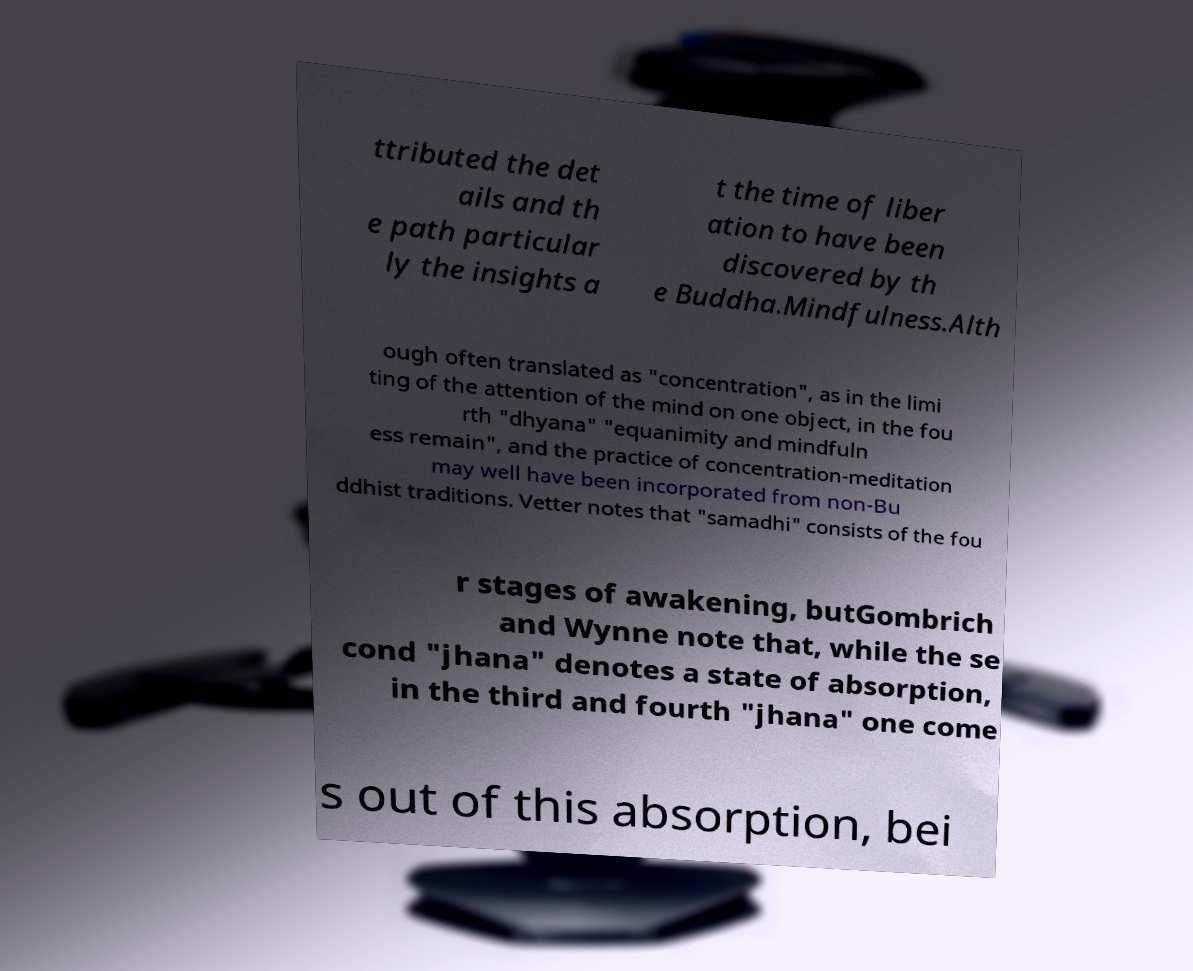Can you accurately transcribe the text from the provided image for me? ttributed the det ails and th e path particular ly the insights a t the time of liber ation to have been discovered by th e Buddha.Mindfulness.Alth ough often translated as "concentration", as in the limi ting of the attention of the mind on one object, in the fou rth "dhyana" "equanimity and mindfuln ess remain", and the practice of concentration-meditation may well have been incorporated from non-Bu ddhist traditions. Vetter notes that "samadhi" consists of the fou r stages of awakening, butGombrich and Wynne note that, while the se cond "jhana" denotes a state of absorption, in the third and fourth "jhana" one come s out of this absorption, bei 